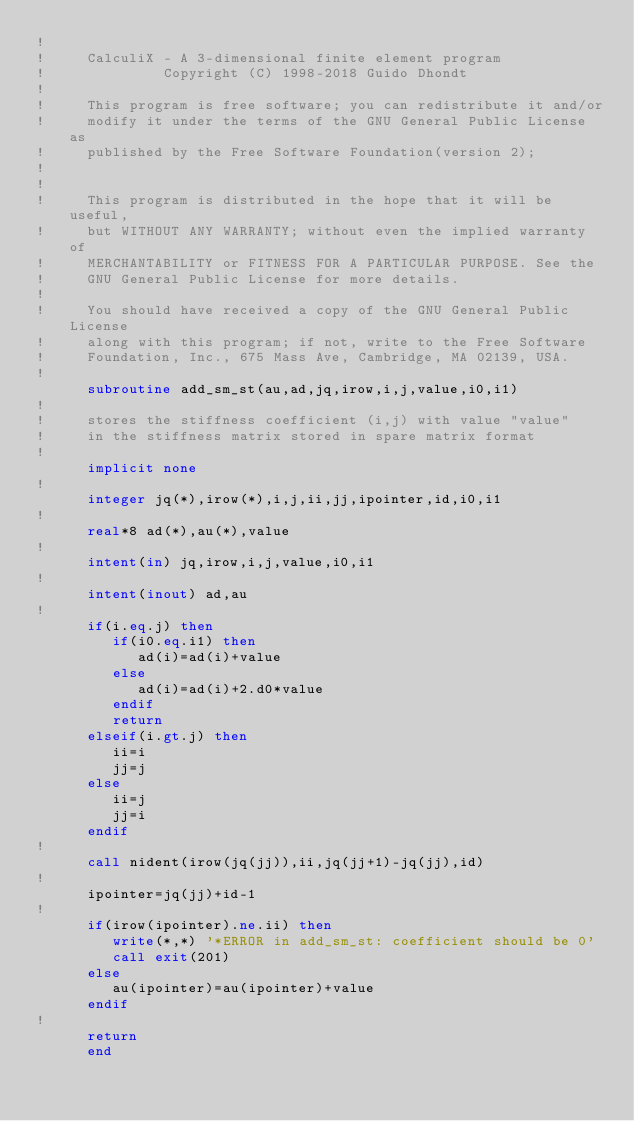<code> <loc_0><loc_0><loc_500><loc_500><_FORTRAN_>!
!     CalculiX - A 3-dimensional finite element program
!              Copyright (C) 1998-2018 Guido Dhondt
!
!     This program is free software; you can redistribute it and/or
!     modify it under the terms of the GNU General Public License as
!     published by the Free Software Foundation(version 2);
!     
!
!     This program is distributed in the hope that it will be useful,
!     but WITHOUT ANY WARRANTY; without even the implied warranty of 
!     MERCHANTABILITY or FITNESS FOR A PARTICULAR PURPOSE. See the 
!     GNU General Public License for more details.
!
!     You should have received a copy of the GNU General Public License
!     along with this program; if not, write to the Free Software
!     Foundation, Inc., 675 Mass Ave, Cambridge, MA 02139, USA.
!
      subroutine add_sm_st(au,ad,jq,irow,i,j,value,i0,i1)
!
!     stores the stiffness coefficient (i,j) with value "value"
!     in the stiffness matrix stored in spare matrix format
!
      implicit none
!
      integer jq(*),irow(*),i,j,ii,jj,ipointer,id,i0,i1
!
      real*8 ad(*),au(*),value
!
      intent(in) jq,irow,i,j,value,i0,i1
!
      intent(inout) ad,au
!
      if(i.eq.j) then
         if(i0.eq.i1) then
            ad(i)=ad(i)+value
         else
            ad(i)=ad(i)+2.d0*value
         endif
         return
      elseif(i.gt.j) then
         ii=i
         jj=j
      else
         ii=j
         jj=i
      endif
!
      call nident(irow(jq(jj)),ii,jq(jj+1)-jq(jj),id)
!
      ipointer=jq(jj)+id-1
!
      if(irow(ipointer).ne.ii) then
         write(*,*) '*ERROR in add_sm_st: coefficient should be 0'
         call exit(201)
      else
         au(ipointer)=au(ipointer)+value
      endif
!
      return
      end













</code> 